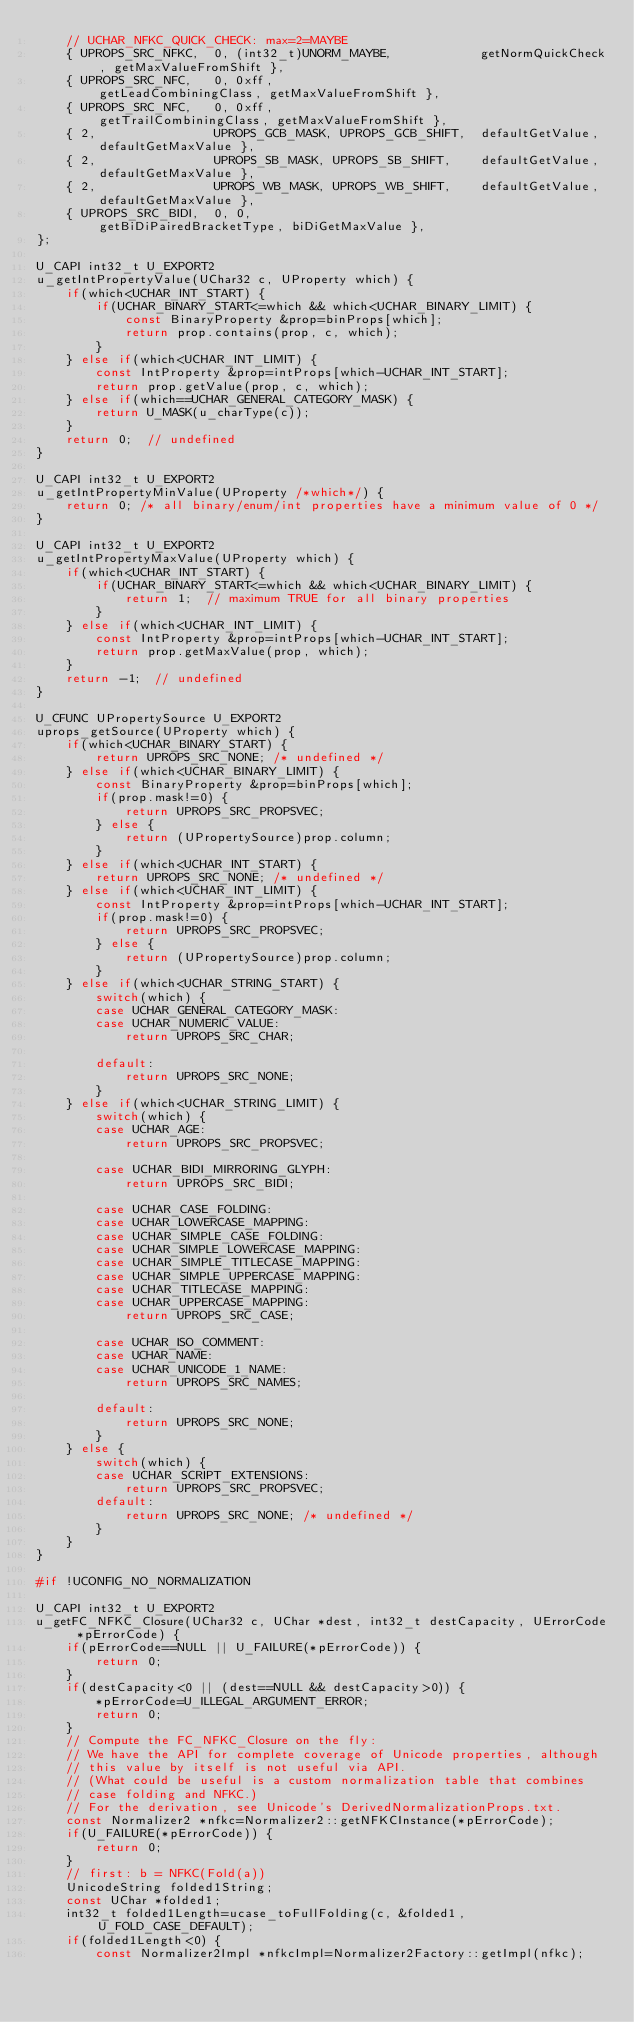Convert code to text. <code><loc_0><loc_0><loc_500><loc_500><_C++_>    // UCHAR_NFKC_QUICK_CHECK: max=2=MAYBE
    { UPROPS_SRC_NFKC,  0, (int32_t)UNORM_MAYBE,            getNormQuickCheck, getMaxValueFromShift },
    { UPROPS_SRC_NFC,   0, 0xff,                            getLeadCombiningClass, getMaxValueFromShift },
    { UPROPS_SRC_NFC,   0, 0xff,                            getTrailCombiningClass, getMaxValueFromShift },
    { 2,                UPROPS_GCB_MASK, UPROPS_GCB_SHIFT,  defaultGetValue, defaultGetMaxValue },
    { 2,                UPROPS_SB_MASK, UPROPS_SB_SHIFT,    defaultGetValue, defaultGetMaxValue },
    { 2,                UPROPS_WB_MASK, UPROPS_WB_SHIFT,    defaultGetValue, defaultGetMaxValue },
    { UPROPS_SRC_BIDI,  0, 0,                               getBiDiPairedBracketType, biDiGetMaxValue },
};

U_CAPI int32_t U_EXPORT2
u_getIntPropertyValue(UChar32 c, UProperty which) {
    if(which<UCHAR_INT_START) {
        if(UCHAR_BINARY_START<=which && which<UCHAR_BINARY_LIMIT) {
            const BinaryProperty &prop=binProps[which];
            return prop.contains(prop, c, which);
        }
    } else if(which<UCHAR_INT_LIMIT) {
        const IntProperty &prop=intProps[which-UCHAR_INT_START];
        return prop.getValue(prop, c, which);
    } else if(which==UCHAR_GENERAL_CATEGORY_MASK) {
        return U_MASK(u_charType(c));
    }
    return 0;  // undefined
}

U_CAPI int32_t U_EXPORT2
u_getIntPropertyMinValue(UProperty /*which*/) {
    return 0; /* all binary/enum/int properties have a minimum value of 0 */
}

U_CAPI int32_t U_EXPORT2
u_getIntPropertyMaxValue(UProperty which) {
    if(which<UCHAR_INT_START) {
        if(UCHAR_BINARY_START<=which && which<UCHAR_BINARY_LIMIT) {
            return 1;  // maximum TRUE for all binary properties
        }
    } else if(which<UCHAR_INT_LIMIT) {
        const IntProperty &prop=intProps[which-UCHAR_INT_START];
        return prop.getMaxValue(prop, which);
    }
    return -1;  // undefined
}

U_CFUNC UPropertySource U_EXPORT2
uprops_getSource(UProperty which) {
    if(which<UCHAR_BINARY_START) {
        return UPROPS_SRC_NONE; /* undefined */
    } else if(which<UCHAR_BINARY_LIMIT) {
        const BinaryProperty &prop=binProps[which];
        if(prop.mask!=0) {
            return UPROPS_SRC_PROPSVEC;
        } else {
            return (UPropertySource)prop.column;
        }
    } else if(which<UCHAR_INT_START) {
        return UPROPS_SRC_NONE; /* undefined */
    } else if(which<UCHAR_INT_LIMIT) {
        const IntProperty &prop=intProps[which-UCHAR_INT_START];
        if(prop.mask!=0) {
            return UPROPS_SRC_PROPSVEC;
        } else {
            return (UPropertySource)prop.column;
        }
    } else if(which<UCHAR_STRING_START) {
        switch(which) {
        case UCHAR_GENERAL_CATEGORY_MASK:
        case UCHAR_NUMERIC_VALUE:
            return UPROPS_SRC_CHAR;

        default:
            return UPROPS_SRC_NONE;
        }
    } else if(which<UCHAR_STRING_LIMIT) {
        switch(which) {
        case UCHAR_AGE:
            return UPROPS_SRC_PROPSVEC;

        case UCHAR_BIDI_MIRRORING_GLYPH:
            return UPROPS_SRC_BIDI;

        case UCHAR_CASE_FOLDING:
        case UCHAR_LOWERCASE_MAPPING:
        case UCHAR_SIMPLE_CASE_FOLDING:
        case UCHAR_SIMPLE_LOWERCASE_MAPPING:
        case UCHAR_SIMPLE_TITLECASE_MAPPING:
        case UCHAR_SIMPLE_UPPERCASE_MAPPING:
        case UCHAR_TITLECASE_MAPPING:
        case UCHAR_UPPERCASE_MAPPING:
            return UPROPS_SRC_CASE;

        case UCHAR_ISO_COMMENT:
        case UCHAR_NAME:
        case UCHAR_UNICODE_1_NAME:
            return UPROPS_SRC_NAMES;

        default:
            return UPROPS_SRC_NONE;
        }
    } else {
        switch(which) {
        case UCHAR_SCRIPT_EXTENSIONS:
            return UPROPS_SRC_PROPSVEC;
        default:
            return UPROPS_SRC_NONE; /* undefined */
        }
    }
}

#if !UCONFIG_NO_NORMALIZATION

U_CAPI int32_t U_EXPORT2
u_getFC_NFKC_Closure(UChar32 c, UChar *dest, int32_t destCapacity, UErrorCode *pErrorCode) {
    if(pErrorCode==NULL || U_FAILURE(*pErrorCode)) {
        return 0;
    }
    if(destCapacity<0 || (dest==NULL && destCapacity>0)) {
        *pErrorCode=U_ILLEGAL_ARGUMENT_ERROR;
        return 0;
    }
    // Compute the FC_NFKC_Closure on the fly:
    // We have the API for complete coverage of Unicode properties, although
    // this value by itself is not useful via API.
    // (What could be useful is a custom normalization table that combines
    // case folding and NFKC.)
    // For the derivation, see Unicode's DerivedNormalizationProps.txt.
    const Normalizer2 *nfkc=Normalizer2::getNFKCInstance(*pErrorCode);
    if(U_FAILURE(*pErrorCode)) {
        return 0;
    }
    // first: b = NFKC(Fold(a))
    UnicodeString folded1String;
    const UChar *folded1;
    int32_t folded1Length=ucase_toFullFolding(c, &folded1, U_FOLD_CASE_DEFAULT);
    if(folded1Length<0) {
        const Normalizer2Impl *nfkcImpl=Normalizer2Factory::getImpl(nfkc);</code> 